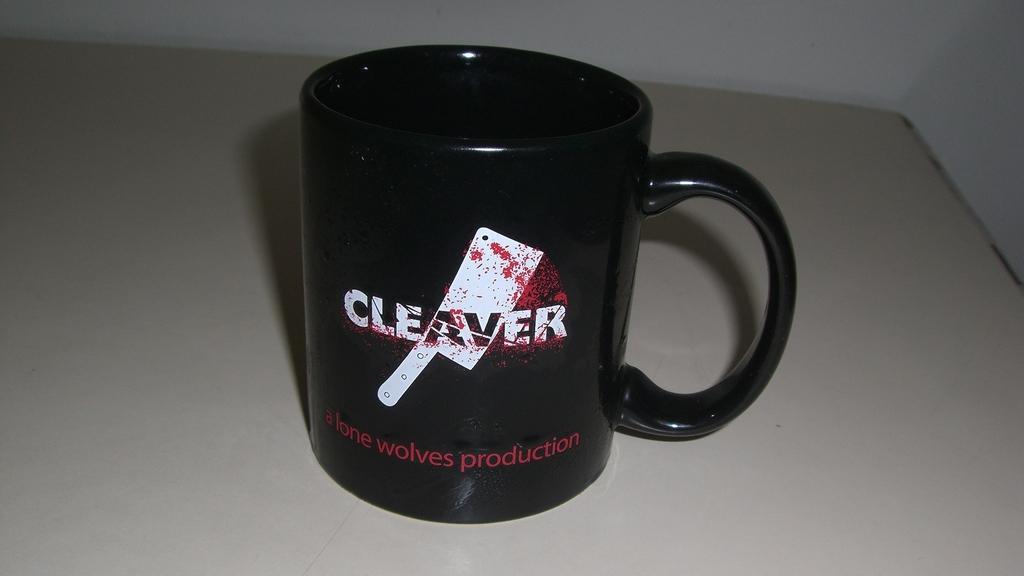Provide a one-sentence caption for the provided image. A coffee cup that has a picture of a meat cleaver on it. 